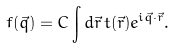<formula> <loc_0><loc_0><loc_500><loc_500>f ( { \vec { q } } ) = C \int d { \vec { r } } \, t ( { \vec { r } } ) e ^ { i { \vec { q } } \cdot { \vec { r } } } .</formula> 